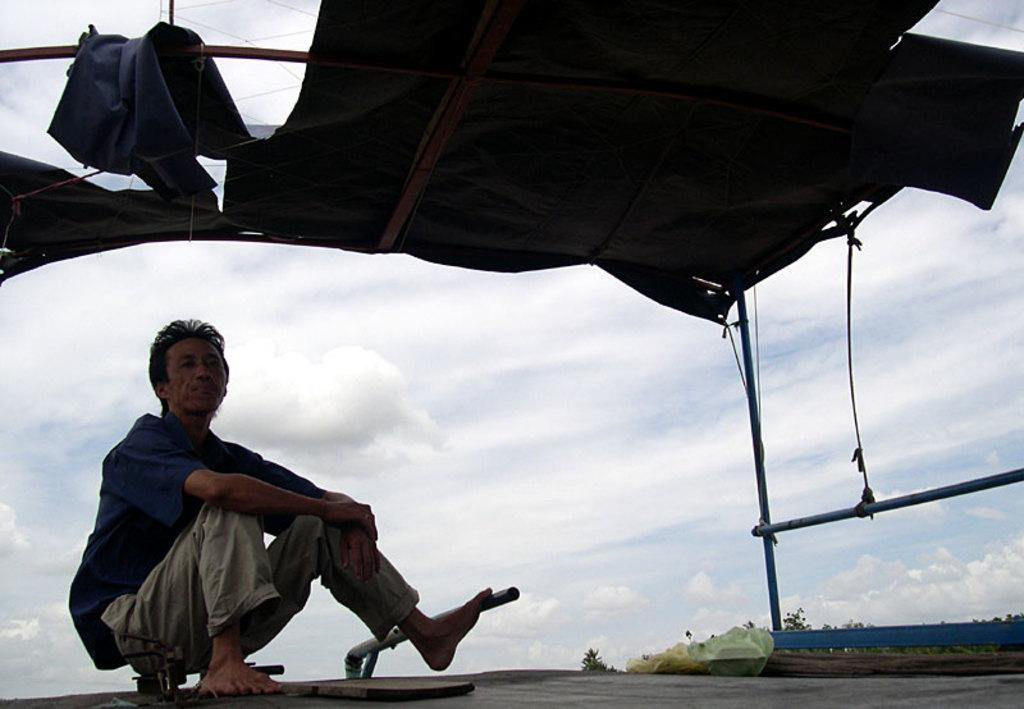What is the person in the image doing? The person is sitting in the image. How is the person's appearance affected by the image? The person is under a black color tint. What can be seen in the background of the image? There is a cloudy sky in the background of the image. What type of vegetation is visible in the image? Trees are visible in the image. Reasoning: Let' Let's think step by step in order to produce the conversation. We start by identifying the main subject in the image, which is the person sitting. Then, we describe the person's appearance, noting that they are under a black color tint. Next, we expand the conversation to include the background of the image, which features a cloudy sky. Finally, we mention the presence of trees, which are a type of vegetation visible in the image. Absurd Question/Answer: How many cows are grazing in the image? There are no cows present in the image. What type of land is visible in the image? The image does not show any specific type of land; it only features a person sitting, a black color tint, a cloudy sky, and trees. What thought is the person having while sitting in the image? The image does not provide any information about the person's thoughts, so it cannot be determined from the image. 